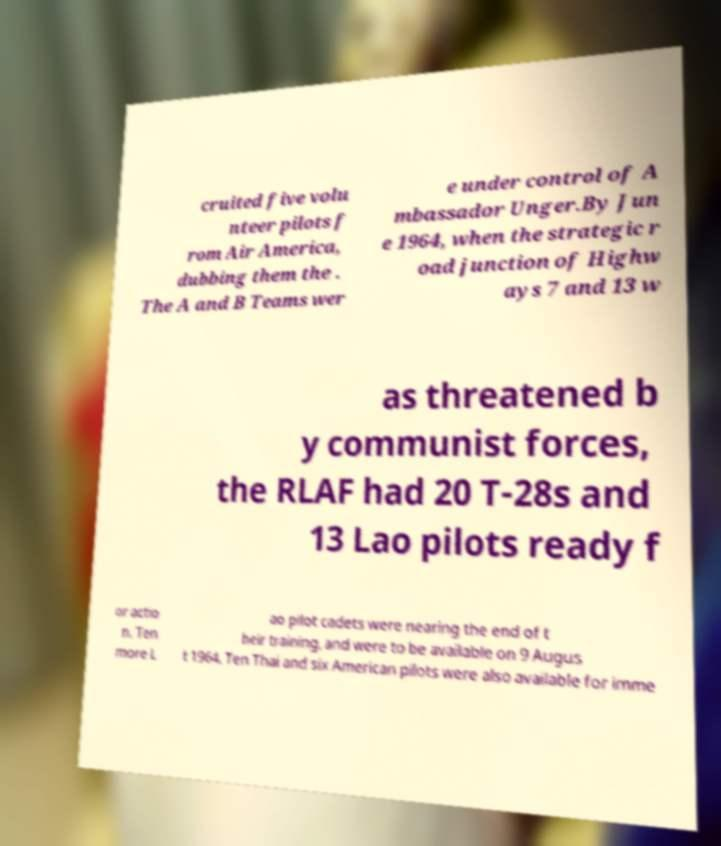What messages or text are displayed in this image? I need them in a readable, typed format. cruited five volu nteer pilots f rom Air America, dubbing them the . The A and B Teams wer e under control of A mbassador Unger.By Jun e 1964, when the strategic r oad junction of Highw ays 7 and 13 w as threatened b y communist forces, the RLAF had 20 T-28s and 13 Lao pilots ready f or actio n. Ten more L ao pilot cadets were nearing the end of t heir training, and were to be available on 9 Augus t 1964. Ten Thai and six American pilots were also available for imme 